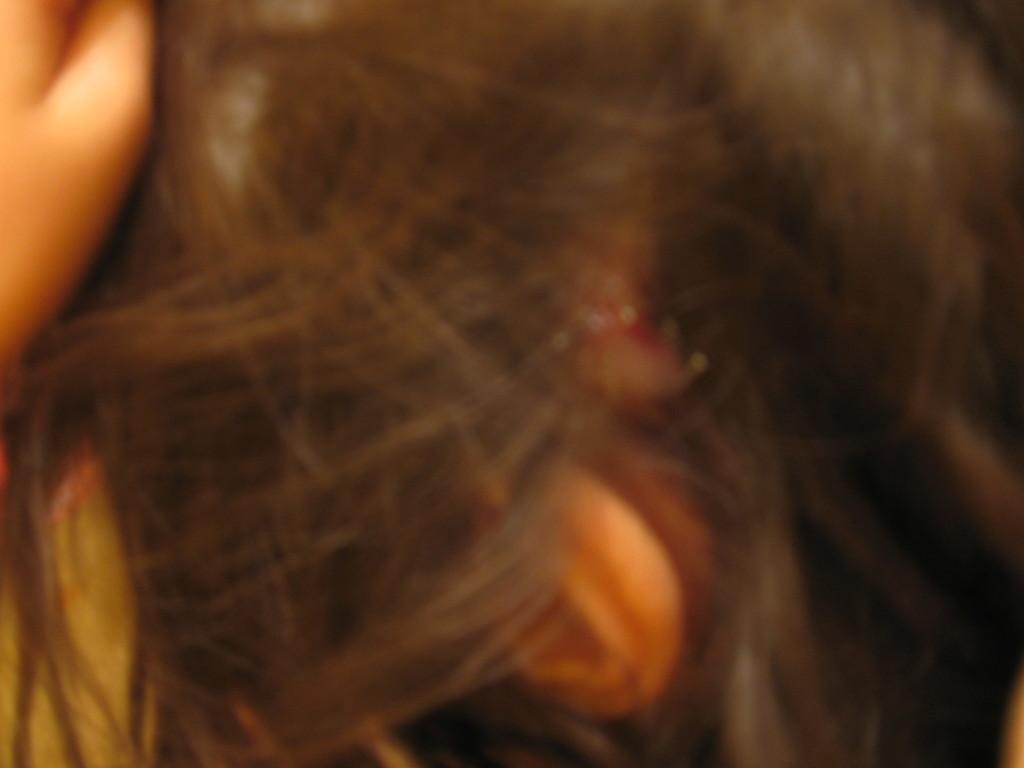What is present in the image? There is a hair in the image. What type of square-shaped jelly can be seen on the route in the image? There is no square-shaped jelly or route present in the image; it only contains a hair. 